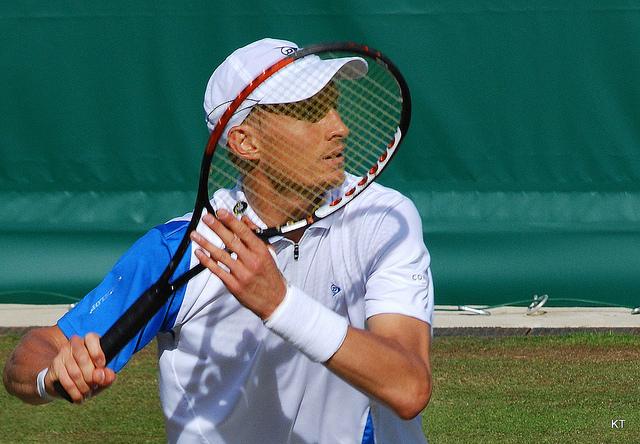Is he going to hit the ball?
Be succinct. Yes. Would this person likely wear a dress?
Quick response, please. No. What is he holding?
Answer briefly. Tennis racket. 